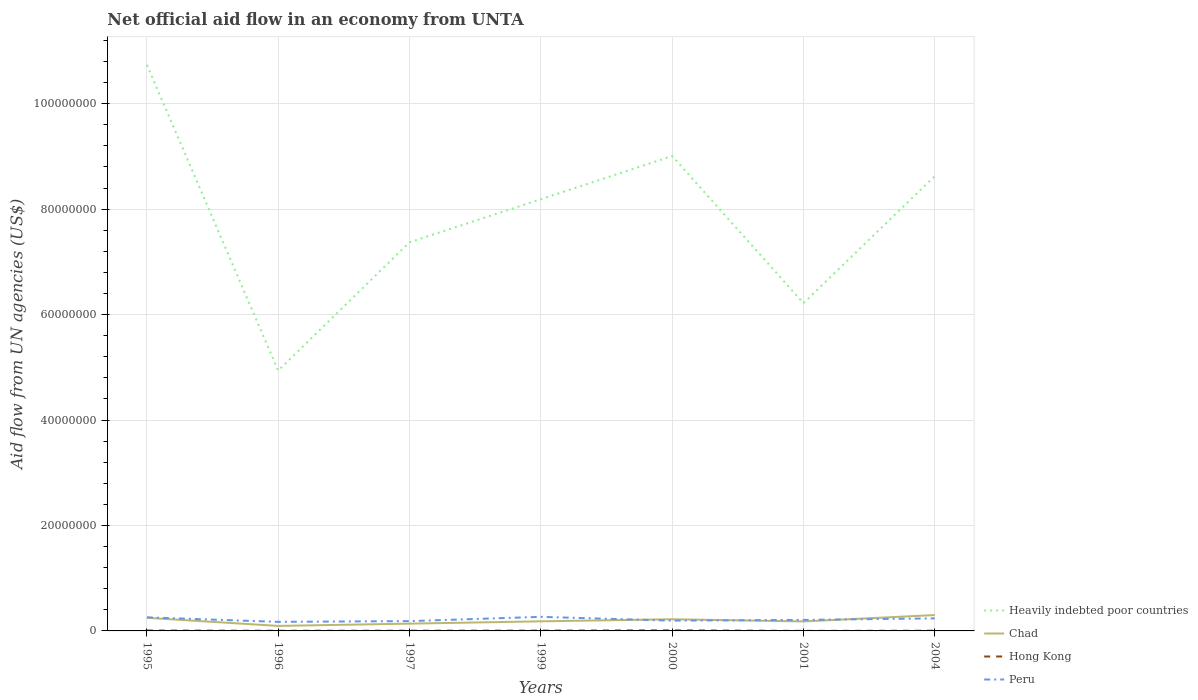Is the number of lines equal to the number of legend labels?
Your answer should be very brief. Yes. Across all years, what is the maximum net official aid flow in Hong Kong?
Offer a terse response. 10000. What is the total net official aid flow in Chad in the graph?
Your answer should be very brief. -8.50e+05. What is the difference between the highest and the second highest net official aid flow in Heavily indebted poor countries?
Ensure brevity in your answer.  5.80e+07. What is the difference between the highest and the lowest net official aid flow in Heavily indebted poor countries?
Your response must be concise. 4. Is the net official aid flow in Peru strictly greater than the net official aid flow in Hong Kong over the years?
Keep it short and to the point. No. How many years are there in the graph?
Give a very brief answer. 7. Does the graph contain any zero values?
Offer a very short reply. No. What is the title of the graph?
Ensure brevity in your answer.  Net official aid flow in an economy from UNTA. Does "Comoros" appear as one of the legend labels in the graph?
Ensure brevity in your answer.  No. What is the label or title of the X-axis?
Give a very brief answer. Years. What is the label or title of the Y-axis?
Your response must be concise. Aid flow from UN agencies (US$). What is the Aid flow from UN agencies (US$) in Heavily indebted poor countries in 1995?
Offer a very short reply. 1.07e+08. What is the Aid flow from UN agencies (US$) of Chad in 1995?
Provide a short and direct response. 2.49e+06. What is the Aid flow from UN agencies (US$) of Hong Kong in 1995?
Offer a very short reply. 8.00e+04. What is the Aid flow from UN agencies (US$) of Peru in 1995?
Provide a succinct answer. 2.58e+06. What is the Aid flow from UN agencies (US$) in Heavily indebted poor countries in 1996?
Ensure brevity in your answer.  4.94e+07. What is the Aid flow from UN agencies (US$) in Chad in 1996?
Make the answer very short. 9.50e+05. What is the Aid flow from UN agencies (US$) in Hong Kong in 1996?
Make the answer very short. 3.00e+04. What is the Aid flow from UN agencies (US$) of Peru in 1996?
Offer a terse response. 1.72e+06. What is the Aid flow from UN agencies (US$) in Heavily indebted poor countries in 1997?
Keep it short and to the point. 7.37e+07. What is the Aid flow from UN agencies (US$) in Chad in 1997?
Your response must be concise. 1.38e+06. What is the Aid flow from UN agencies (US$) in Peru in 1997?
Keep it short and to the point. 1.86e+06. What is the Aid flow from UN agencies (US$) in Heavily indebted poor countries in 1999?
Your response must be concise. 8.19e+07. What is the Aid flow from UN agencies (US$) in Chad in 1999?
Keep it short and to the point. 1.82e+06. What is the Aid flow from UN agencies (US$) in Peru in 1999?
Provide a succinct answer. 2.67e+06. What is the Aid flow from UN agencies (US$) in Heavily indebted poor countries in 2000?
Offer a very short reply. 9.01e+07. What is the Aid flow from UN agencies (US$) in Chad in 2000?
Offer a terse response. 2.21e+06. What is the Aid flow from UN agencies (US$) of Peru in 2000?
Your response must be concise. 1.95e+06. What is the Aid flow from UN agencies (US$) in Heavily indebted poor countries in 2001?
Your answer should be very brief. 6.22e+07. What is the Aid flow from UN agencies (US$) in Chad in 2001?
Offer a very short reply. 1.80e+06. What is the Aid flow from UN agencies (US$) of Peru in 2001?
Provide a short and direct response. 2.09e+06. What is the Aid flow from UN agencies (US$) in Heavily indebted poor countries in 2004?
Offer a terse response. 8.63e+07. What is the Aid flow from UN agencies (US$) in Chad in 2004?
Offer a terse response. 3.01e+06. What is the Aid flow from UN agencies (US$) in Hong Kong in 2004?
Your answer should be compact. 4.00e+04. What is the Aid flow from UN agencies (US$) of Peru in 2004?
Your answer should be very brief. 2.38e+06. Across all years, what is the maximum Aid flow from UN agencies (US$) of Heavily indebted poor countries?
Make the answer very short. 1.07e+08. Across all years, what is the maximum Aid flow from UN agencies (US$) in Chad?
Provide a short and direct response. 3.01e+06. Across all years, what is the maximum Aid flow from UN agencies (US$) of Hong Kong?
Offer a terse response. 1.10e+05. Across all years, what is the maximum Aid flow from UN agencies (US$) in Peru?
Make the answer very short. 2.67e+06. Across all years, what is the minimum Aid flow from UN agencies (US$) in Heavily indebted poor countries?
Offer a terse response. 4.94e+07. Across all years, what is the minimum Aid flow from UN agencies (US$) of Chad?
Give a very brief answer. 9.50e+05. Across all years, what is the minimum Aid flow from UN agencies (US$) of Peru?
Offer a very short reply. 1.72e+06. What is the total Aid flow from UN agencies (US$) of Heavily indebted poor countries in the graph?
Provide a short and direct response. 5.51e+08. What is the total Aid flow from UN agencies (US$) in Chad in the graph?
Give a very brief answer. 1.37e+07. What is the total Aid flow from UN agencies (US$) of Hong Kong in the graph?
Your response must be concise. 3.70e+05. What is the total Aid flow from UN agencies (US$) in Peru in the graph?
Offer a terse response. 1.52e+07. What is the difference between the Aid flow from UN agencies (US$) of Heavily indebted poor countries in 1995 and that in 1996?
Your response must be concise. 5.80e+07. What is the difference between the Aid flow from UN agencies (US$) of Chad in 1995 and that in 1996?
Offer a terse response. 1.54e+06. What is the difference between the Aid flow from UN agencies (US$) in Peru in 1995 and that in 1996?
Give a very brief answer. 8.60e+05. What is the difference between the Aid flow from UN agencies (US$) in Heavily indebted poor countries in 1995 and that in 1997?
Offer a very short reply. 3.36e+07. What is the difference between the Aid flow from UN agencies (US$) of Chad in 1995 and that in 1997?
Your response must be concise. 1.11e+06. What is the difference between the Aid flow from UN agencies (US$) in Peru in 1995 and that in 1997?
Provide a succinct answer. 7.20e+05. What is the difference between the Aid flow from UN agencies (US$) in Heavily indebted poor countries in 1995 and that in 1999?
Keep it short and to the point. 2.55e+07. What is the difference between the Aid flow from UN agencies (US$) of Chad in 1995 and that in 1999?
Your response must be concise. 6.70e+05. What is the difference between the Aid flow from UN agencies (US$) in Hong Kong in 1995 and that in 1999?
Your response must be concise. 2.00e+04. What is the difference between the Aid flow from UN agencies (US$) in Peru in 1995 and that in 1999?
Provide a short and direct response. -9.00e+04. What is the difference between the Aid flow from UN agencies (US$) in Heavily indebted poor countries in 1995 and that in 2000?
Offer a very short reply. 1.73e+07. What is the difference between the Aid flow from UN agencies (US$) of Chad in 1995 and that in 2000?
Your answer should be compact. 2.80e+05. What is the difference between the Aid flow from UN agencies (US$) in Hong Kong in 1995 and that in 2000?
Your answer should be very brief. -3.00e+04. What is the difference between the Aid flow from UN agencies (US$) of Peru in 1995 and that in 2000?
Give a very brief answer. 6.30e+05. What is the difference between the Aid flow from UN agencies (US$) of Heavily indebted poor countries in 1995 and that in 2001?
Offer a very short reply. 4.52e+07. What is the difference between the Aid flow from UN agencies (US$) in Chad in 1995 and that in 2001?
Ensure brevity in your answer.  6.90e+05. What is the difference between the Aid flow from UN agencies (US$) of Peru in 1995 and that in 2001?
Your answer should be very brief. 4.90e+05. What is the difference between the Aid flow from UN agencies (US$) in Heavily indebted poor countries in 1995 and that in 2004?
Give a very brief answer. 2.11e+07. What is the difference between the Aid flow from UN agencies (US$) of Chad in 1995 and that in 2004?
Offer a terse response. -5.20e+05. What is the difference between the Aid flow from UN agencies (US$) in Heavily indebted poor countries in 1996 and that in 1997?
Keep it short and to the point. -2.43e+07. What is the difference between the Aid flow from UN agencies (US$) in Chad in 1996 and that in 1997?
Give a very brief answer. -4.30e+05. What is the difference between the Aid flow from UN agencies (US$) in Hong Kong in 1996 and that in 1997?
Provide a short and direct response. -10000. What is the difference between the Aid flow from UN agencies (US$) in Heavily indebted poor countries in 1996 and that in 1999?
Offer a very short reply. -3.25e+07. What is the difference between the Aid flow from UN agencies (US$) in Chad in 1996 and that in 1999?
Offer a terse response. -8.70e+05. What is the difference between the Aid flow from UN agencies (US$) in Hong Kong in 1996 and that in 1999?
Your answer should be very brief. -3.00e+04. What is the difference between the Aid flow from UN agencies (US$) of Peru in 1996 and that in 1999?
Provide a succinct answer. -9.50e+05. What is the difference between the Aid flow from UN agencies (US$) of Heavily indebted poor countries in 1996 and that in 2000?
Make the answer very short. -4.07e+07. What is the difference between the Aid flow from UN agencies (US$) of Chad in 1996 and that in 2000?
Give a very brief answer. -1.26e+06. What is the difference between the Aid flow from UN agencies (US$) in Heavily indebted poor countries in 1996 and that in 2001?
Ensure brevity in your answer.  -1.28e+07. What is the difference between the Aid flow from UN agencies (US$) of Chad in 1996 and that in 2001?
Make the answer very short. -8.50e+05. What is the difference between the Aid flow from UN agencies (US$) of Hong Kong in 1996 and that in 2001?
Ensure brevity in your answer.  2.00e+04. What is the difference between the Aid flow from UN agencies (US$) in Peru in 1996 and that in 2001?
Ensure brevity in your answer.  -3.70e+05. What is the difference between the Aid flow from UN agencies (US$) in Heavily indebted poor countries in 1996 and that in 2004?
Your answer should be very brief. -3.69e+07. What is the difference between the Aid flow from UN agencies (US$) of Chad in 1996 and that in 2004?
Provide a short and direct response. -2.06e+06. What is the difference between the Aid flow from UN agencies (US$) in Peru in 1996 and that in 2004?
Your response must be concise. -6.60e+05. What is the difference between the Aid flow from UN agencies (US$) of Heavily indebted poor countries in 1997 and that in 1999?
Your answer should be compact. -8.16e+06. What is the difference between the Aid flow from UN agencies (US$) of Chad in 1997 and that in 1999?
Offer a very short reply. -4.40e+05. What is the difference between the Aid flow from UN agencies (US$) of Hong Kong in 1997 and that in 1999?
Provide a succinct answer. -2.00e+04. What is the difference between the Aid flow from UN agencies (US$) of Peru in 1997 and that in 1999?
Ensure brevity in your answer.  -8.10e+05. What is the difference between the Aid flow from UN agencies (US$) in Heavily indebted poor countries in 1997 and that in 2000?
Offer a very short reply. -1.64e+07. What is the difference between the Aid flow from UN agencies (US$) in Chad in 1997 and that in 2000?
Provide a succinct answer. -8.30e+05. What is the difference between the Aid flow from UN agencies (US$) in Heavily indebted poor countries in 1997 and that in 2001?
Your answer should be very brief. 1.16e+07. What is the difference between the Aid flow from UN agencies (US$) in Chad in 1997 and that in 2001?
Offer a very short reply. -4.20e+05. What is the difference between the Aid flow from UN agencies (US$) of Hong Kong in 1997 and that in 2001?
Provide a short and direct response. 3.00e+04. What is the difference between the Aid flow from UN agencies (US$) in Heavily indebted poor countries in 1997 and that in 2004?
Ensure brevity in your answer.  -1.25e+07. What is the difference between the Aid flow from UN agencies (US$) of Chad in 1997 and that in 2004?
Give a very brief answer. -1.63e+06. What is the difference between the Aid flow from UN agencies (US$) in Peru in 1997 and that in 2004?
Provide a short and direct response. -5.20e+05. What is the difference between the Aid flow from UN agencies (US$) of Heavily indebted poor countries in 1999 and that in 2000?
Provide a succinct answer. -8.20e+06. What is the difference between the Aid flow from UN agencies (US$) in Chad in 1999 and that in 2000?
Keep it short and to the point. -3.90e+05. What is the difference between the Aid flow from UN agencies (US$) of Peru in 1999 and that in 2000?
Give a very brief answer. 7.20e+05. What is the difference between the Aid flow from UN agencies (US$) of Heavily indebted poor countries in 1999 and that in 2001?
Offer a terse response. 1.97e+07. What is the difference between the Aid flow from UN agencies (US$) of Peru in 1999 and that in 2001?
Provide a succinct answer. 5.80e+05. What is the difference between the Aid flow from UN agencies (US$) of Heavily indebted poor countries in 1999 and that in 2004?
Ensure brevity in your answer.  -4.38e+06. What is the difference between the Aid flow from UN agencies (US$) in Chad in 1999 and that in 2004?
Give a very brief answer. -1.19e+06. What is the difference between the Aid flow from UN agencies (US$) in Hong Kong in 1999 and that in 2004?
Your answer should be compact. 2.00e+04. What is the difference between the Aid flow from UN agencies (US$) in Peru in 1999 and that in 2004?
Provide a short and direct response. 2.90e+05. What is the difference between the Aid flow from UN agencies (US$) of Heavily indebted poor countries in 2000 and that in 2001?
Your answer should be compact. 2.79e+07. What is the difference between the Aid flow from UN agencies (US$) in Chad in 2000 and that in 2001?
Your answer should be very brief. 4.10e+05. What is the difference between the Aid flow from UN agencies (US$) in Peru in 2000 and that in 2001?
Your answer should be compact. -1.40e+05. What is the difference between the Aid flow from UN agencies (US$) of Heavily indebted poor countries in 2000 and that in 2004?
Your response must be concise. 3.82e+06. What is the difference between the Aid flow from UN agencies (US$) in Chad in 2000 and that in 2004?
Your response must be concise. -8.00e+05. What is the difference between the Aid flow from UN agencies (US$) in Hong Kong in 2000 and that in 2004?
Your answer should be very brief. 7.00e+04. What is the difference between the Aid flow from UN agencies (US$) of Peru in 2000 and that in 2004?
Your answer should be compact. -4.30e+05. What is the difference between the Aid flow from UN agencies (US$) of Heavily indebted poor countries in 2001 and that in 2004?
Give a very brief answer. -2.41e+07. What is the difference between the Aid flow from UN agencies (US$) of Chad in 2001 and that in 2004?
Your answer should be compact. -1.21e+06. What is the difference between the Aid flow from UN agencies (US$) of Heavily indebted poor countries in 1995 and the Aid flow from UN agencies (US$) of Chad in 1996?
Provide a succinct answer. 1.06e+08. What is the difference between the Aid flow from UN agencies (US$) of Heavily indebted poor countries in 1995 and the Aid flow from UN agencies (US$) of Hong Kong in 1996?
Your response must be concise. 1.07e+08. What is the difference between the Aid flow from UN agencies (US$) in Heavily indebted poor countries in 1995 and the Aid flow from UN agencies (US$) in Peru in 1996?
Offer a terse response. 1.06e+08. What is the difference between the Aid flow from UN agencies (US$) in Chad in 1995 and the Aid flow from UN agencies (US$) in Hong Kong in 1996?
Your answer should be very brief. 2.46e+06. What is the difference between the Aid flow from UN agencies (US$) of Chad in 1995 and the Aid flow from UN agencies (US$) of Peru in 1996?
Provide a short and direct response. 7.70e+05. What is the difference between the Aid flow from UN agencies (US$) of Hong Kong in 1995 and the Aid flow from UN agencies (US$) of Peru in 1996?
Offer a terse response. -1.64e+06. What is the difference between the Aid flow from UN agencies (US$) in Heavily indebted poor countries in 1995 and the Aid flow from UN agencies (US$) in Chad in 1997?
Your response must be concise. 1.06e+08. What is the difference between the Aid flow from UN agencies (US$) in Heavily indebted poor countries in 1995 and the Aid flow from UN agencies (US$) in Hong Kong in 1997?
Keep it short and to the point. 1.07e+08. What is the difference between the Aid flow from UN agencies (US$) of Heavily indebted poor countries in 1995 and the Aid flow from UN agencies (US$) of Peru in 1997?
Make the answer very short. 1.06e+08. What is the difference between the Aid flow from UN agencies (US$) in Chad in 1995 and the Aid flow from UN agencies (US$) in Hong Kong in 1997?
Offer a terse response. 2.45e+06. What is the difference between the Aid flow from UN agencies (US$) in Chad in 1995 and the Aid flow from UN agencies (US$) in Peru in 1997?
Keep it short and to the point. 6.30e+05. What is the difference between the Aid flow from UN agencies (US$) in Hong Kong in 1995 and the Aid flow from UN agencies (US$) in Peru in 1997?
Offer a very short reply. -1.78e+06. What is the difference between the Aid flow from UN agencies (US$) of Heavily indebted poor countries in 1995 and the Aid flow from UN agencies (US$) of Chad in 1999?
Give a very brief answer. 1.06e+08. What is the difference between the Aid flow from UN agencies (US$) in Heavily indebted poor countries in 1995 and the Aid flow from UN agencies (US$) in Hong Kong in 1999?
Offer a terse response. 1.07e+08. What is the difference between the Aid flow from UN agencies (US$) of Heavily indebted poor countries in 1995 and the Aid flow from UN agencies (US$) of Peru in 1999?
Your response must be concise. 1.05e+08. What is the difference between the Aid flow from UN agencies (US$) of Chad in 1995 and the Aid flow from UN agencies (US$) of Hong Kong in 1999?
Keep it short and to the point. 2.43e+06. What is the difference between the Aid flow from UN agencies (US$) in Chad in 1995 and the Aid flow from UN agencies (US$) in Peru in 1999?
Ensure brevity in your answer.  -1.80e+05. What is the difference between the Aid flow from UN agencies (US$) in Hong Kong in 1995 and the Aid flow from UN agencies (US$) in Peru in 1999?
Make the answer very short. -2.59e+06. What is the difference between the Aid flow from UN agencies (US$) of Heavily indebted poor countries in 1995 and the Aid flow from UN agencies (US$) of Chad in 2000?
Offer a terse response. 1.05e+08. What is the difference between the Aid flow from UN agencies (US$) of Heavily indebted poor countries in 1995 and the Aid flow from UN agencies (US$) of Hong Kong in 2000?
Offer a very short reply. 1.07e+08. What is the difference between the Aid flow from UN agencies (US$) of Heavily indebted poor countries in 1995 and the Aid flow from UN agencies (US$) of Peru in 2000?
Keep it short and to the point. 1.05e+08. What is the difference between the Aid flow from UN agencies (US$) of Chad in 1995 and the Aid flow from UN agencies (US$) of Hong Kong in 2000?
Give a very brief answer. 2.38e+06. What is the difference between the Aid flow from UN agencies (US$) in Chad in 1995 and the Aid flow from UN agencies (US$) in Peru in 2000?
Ensure brevity in your answer.  5.40e+05. What is the difference between the Aid flow from UN agencies (US$) in Hong Kong in 1995 and the Aid flow from UN agencies (US$) in Peru in 2000?
Make the answer very short. -1.87e+06. What is the difference between the Aid flow from UN agencies (US$) of Heavily indebted poor countries in 1995 and the Aid flow from UN agencies (US$) of Chad in 2001?
Keep it short and to the point. 1.06e+08. What is the difference between the Aid flow from UN agencies (US$) in Heavily indebted poor countries in 1995 and the Aid flow from UN agencies (US$) in Hong Kong in 2001?
Your answer should be very brief. 1.07e+08. What is the difference between the Aid flow from UN agencies (US$) in Heavily indebted poor countries in 1995 and the Aid flow from UN agencies (US$) in Peru in 2001?
Your answer should be compact. 1.05e+08. What is the difference between the Aid flow from UN agencies (US$) in Chad in 1995 and the Aid flow from UN agencies (US$) in Hong Kong in 2001?
Ensure brevity in your answer.  2.48e+06. What is the difference between the Aid flow from UN agencies (US$) in Hong Kong in 1995 and the Aid flow from UN agencies (US$) in Peru in 2001?
Offer a terse response. -2.01e+06. What is the difference between the Aid flow from UN agencies (US$) in Heavily indebted poor countries in 1995 and the Aid flow from UN agencies (US$) in Chad in 2004?
Make the answer very short. 1.04e+08. What is the difference between the Aid flow from UN agencies (US$) of Heavily indebted poor countries in 1995 and the Aid flow from UN agencies (US$) of Hong Kong in 2004?
Ensure brevity in your answer.  1.07e+08. What is the difference between the Aid flow from UN agencies (US$) of Heavily indebted poor countries in 1995 and the Aid flow from UN agencies (US$) of Peru in 2004?
Make the answer very short. 1.05e+08. What is the difference between the Aid flow from UN agencies (US$) of Chad in 1995 and the Aid flow from UN agencies (US$) of Hong Kong in 2004?
Keep it short and to the point. 2.45e+06. What is the difference between the Aid flow from UN agencies (US$) in Chad in 1995 and the Aid flow from UN agencies (US$) in Peru in 2004?
Give a very brief answer. 1.10e+05. What is the difference between the Aid flow from UN agencies (US$) of Hong Kong in 1995 and the Aid flow from UN agencies (US$) of Peru in 2004?
Provide a succinct answer. -2.30e+06. What is the difference between the Aid flow from UN agencies (US$) in Heavily indebted poor countries in 1996 and the Aid flow from UN agencies (US$) in Chad in 1997?
Make the answer very short. 4.80e+07. What is the difference between the Aid flow from UN agencies (US$) of Heavily indebted poor countries in 1996 and the Aid flow from UN agencies (US$) of Hong Kong in 1997?
Make the answer very short. 4.93e+07. What is the difference between the Aid flow from UN agencies (US$) in Heavily indebted poor countries in 1996 and the Aid flow from UN agencies (US$) in Peru in 1997?
Make the answer very short. 4.75e+07. What is the difference between the Aid flow from UN agencies (US$) in Chad in 1996 and the Aid flow from UN agencies (US$) in Hong Kong in 1997?
Provide a short and direct response. 9.10e+05. What is the difference between the Aid flow from UN agencies (US$) in Chad in 1996 and the Aid flow from UN agencies (US$) in Peru in 1997?
Ensure brevity in your answer.  -9.10e+05. What is the difference between the Aid flow from UN agencies (US$) of Hong Kong in 1996 and the Aid flow from UN agencies (US$) of Peru in 1997?
Make the answer very short. -1.83e+06. What is the difference between the Aid flow from UN agencies (US$) of Heavily indebted poor countries in 1996 and the Aid flow from UN agencies (US$) of Chad in 1999?
Keep it short and to the point. 4.76e+07. What is the difference between the Aid flow from UN agencies (US$) of Heavily indebted poor countries in 1996 and the Aid flow from UN agencies (US$) of Hong Kong in 1999?
Provide a short and direct response. 4.93e+07. What is the difference between the Aid flow from UN agencies (US$) in Heavily indebted poor countries in 1996 and the Aid flow from UN agencies (US$) in Peru in 1999?
Provide a succinct answer. 4.67e+07. What is the difference between the Aid flow from UN agencies (US$) of Chad in 1996 and the Aid flow from UN agencies (US$) of Hong Kong in 1999?
Your answer should be compact. 8.90e+05. What is the difference between the Aid flow from UN agencies (US$) of Chad in 1996 and the Aid flow from UN agencies (US$) of Peru in 1999?
Make the answer very short. -1.72e+06. What is the difference between the Aid flow from UN agencies (US$) of Hong Kong in 1996 and the Aid flow from UN agencies (US$) of Peru in 1999?
Give a very brief answer. -2.64e+06. What is the difference between the Aid flow from UN agencies (US$) of Heavily indebted poor countries in 1996 and the Aid flow from UN agencies (US$) of Chad in 2000?
Keep it short and to the point. 4.72e+07. What is the difference between the Aid flow from UN agencies (US$) in Heavily indebted poor countries in 1996 and the Aid flow from UN agencies (US$) in Hong Kong in 2000?
Give a very brief answer. 4.93e+07. What is the difference between the Aid flow from UN agencies (US$) in Heavily indebted poor countries in 1996 and the Aid flow from UN agencies (US$) in Peru in 2000?
Offer a very short reply. 4.74e+07. What is the difference between the Aid flow from UN agencies (US$) of Chad in 1996 and the Aid flow from UN agencies (US$) of Hong Kong in 2000?
Your answer should be compact. 8.40e+05. What is the difference between the Aid flow from UN agencies (US$) in Chad in 1996 and the Aid flow from UN agencies (US$) in Peru in 2000?
Your answer should be compact. -1.00e+06. What is the difference between the Aid flow from UN agencies (US$) of Hong Kong in 1996 and the Aid flow from UN agencies (US$) of Peru in 2000?
Give a very brief answer. -1.92e+06. What is the difference between the Aid flow from UN agencies (US$) in Heavily indebted poor countries in 1996 and the Aid flow from UN agencies (US$) in Chad in 2001?
Your answer should be compact. 4.76e+07. What is the difference between the Aid flow from UN agencies (US$) in Heavily indebted poor countries in 1996 and the Aid flow from UN agencies (US$) in Hong Kong in 2001?
Keep it short and to the point. 4.94e+07. What is the difference between the Aid flow from UN agencies (US$) of Heavily indebted poor countries in 1996 and the Aid flow from UN agencies (US$) of Peru in 2001?
Offer a terse response. 4.73e+07. What is the difference between the Aid flow from UN agencies (US$) in Chad in 1996 and the Aid flow from UN agencies (US$) in Hong Kong in 2001?
Provide a short and direct response. 9.40e+05. What is the difference between the Aid flow from UN agencies (US$) of Chad in 1996 and the Aid flow from UN agencies (US$) of Peru in 2001?
Your answer should be very brief. -1.14e+06. What is the difference between the Aid flow from UN agencies (US$) of Hong Kong in 1996 and the Aid flow from UN agencies (US$) of Peru in 2001?
Keep it short and to the point. -2.06e+06. What is the difference between the Aid flow from UN agencies (US$) in Heavily indebted poor countries in 1996 and the Aid flow from UN agencies (US$) in Chad in 2004?
Offer a very short reply. 4.64e+07. What is the difference between the Aid flow from UN agencies (US$) in Heavily indebted poor countries in 1996 and the Aid flow from UN agencies (US$) in Hong Kong in 2004?
Make the answer very short. 4.93e+07. What is the difference between the Aid flow from UN agencies (US$) in Heavily indebted poor countries in 1996 and the Aid flow from UN agencies (US$) in Peru in 2004?
Give a very brief answer. 4.70e+07. What is the difference between the Aid flow from UN agencies (US$) of Chad in 1996 and the Aid flow from UN agencies (US$) of Hong Kong in 2004?
Ensure brevity in your answer.  9.10e+05. What is the difference between the Aid flow from UN agencies (US$) of Chad in 1996 and the Aid flow from UN agencies (US$) of Peru in 2004?
Offer a very short reply. -1.43e+06. What is the difference between the Aid flow from UN agencies (US$) in Hong Kong in 1996 and the Aid flow from UN agencies (US$) in Peru in 2004?
Keep it short and to the point. -2.35e+06. What is the difference between the Aid flow from UN agencies (US$) of Heavily indebted poor countries in 1997 and the Aid flow from UN agencies (US$) of Chad in 1999?
Provide a succinct answer. 7.19e+07. What is the difference between the Aid flow from UN agencies (US$) in Heavily indebted poor countries in 1997 and the Aid flow from UN agencies (US$) in Hong Kong in 1999?
Provide a short and direct response. 7.37e+07. What is the difference between the Aid flow from UN agencies (US$) in Heavily indebted poor countries in 1997 and the Aid flow from UN agencies (US$) in Peru in 1999?
Your answer should be very brief. 7.10e+07. What is the difference between the Aid flow from UN agencies (US$) in Chad in 1997 and the Aid flow from UN agencies (US$) in Hong Kong in 1999?
Offer a very short reply. 1.32e+06. What is the difference between the Aid flow from UN agencies (US$) of Chad in 1997 and the Aid flow from UN agencies (US$) of Peru in 1999?
Offer a very short reply. -1.29e+06. What is the difference between the Aid flow from UN agencies (US$) of Hong Kong in 1997 and the Aid flow from UN agencies (US$) of Peru in 1999?
Your response must be concise. -2.63e+06. What is the difference between the Aid flow from UN agencies (US$) of Heavily indebted poor countries in 1997 and the Aid flow from UN agencies (US$) of Chad in 2000?
Provide a short and direct response. 7.15e+07. What is the difference between the Aid flow from UN agencies (US$) in Heavily indebted poor countries in 1997 and the Aid flow from UN agencies (US$) in Hong Kong in 2000?
Ensure brevity in your answer.  7.36e+07. What is the difference between the Aid flow from UN agencies (US$) of Heavily indebted poor countries in 1997 and the Aid flow from UN agencies (US$) of Peru in 2000?
Provide a succinct answer. 7.18e+07. What is the difference between the Aid flow from UN agencies (US$) of Chad in 1997 and the Aid flow from UN agencies (US$) of Hong Kong in 2000?
Your answer should be very brief. 1.27e+06. What is the difference between the Aid flow from UN agencies (US$) in Chad in 1997 and the Aid flow from UN agencies (US$) in Peru in 2000?
Keep it short and to the point. -5.70e+05. What is the difference between the Aid flow from UN agencies (US$) of Hong Kong in 1997 and the Aid flow from UN agencies (US$) of Peru in 2000?
Provide a succinct answer. -1.91e+06. What is the difference between the Aid flow from UN agencies (US$) of Heavily indebted poor countries in 1997 and the Aid flow from UN agencies (US$) of Chad in 2001?
Your answer should be compact. 7.19e+07. What is the difference between the Aid flow from UN agencies (US$) of Heavily indebted poor countries in 1997 and the Aid flow from UN agencies (US$) of Hong Kong in 2001?
Your answer should be compact. 7.37e+07. What is the difference between the Aid flow from UN agencies (US$) in Heavily indebted poor countries in 1997 and the Aid flow from UN agencies (US$) in Peru in 2001?
Offer a terse response. 7.16e+07. What is the difference between the Aid flow from UN agencies (US$) of Chad in 1997 and the Aid flow from UN agencies (US$) of Hong Kong in 2001?
Offer a very short reply. 1.37e+06. What is the difference between the Aid flow from UN agencies (US$) of Chad in 1997 and the Aid flow from UN agencies (US$) of Peru in 2001?
Give a very brief answer. -7.10e+05. What is the difference between the Aid flow from UN agencies (US$) of Hong Kong in 1997 and the Aid flow from UN agencies (US$) of Peru in 2001?
Provide a short and direct response. -2.05e+06. What is the difference between the Aid flow from UN agencies (US$) in Heavily indebted poor countries in 1997 and the Aid flow from UN agencies (US$) in Chad in 2004?
Offer a terse response. 7.07e+07. What is the difference between the Aid flow from UN agencies (US$) of Heavily indebted poor countries in 1997 and the Aid flow from UN agencies (US$) of Hong Kong in 2004?
Your answer should be very brief. 7.37e+07. What is the difference between the Aid flow from UN agencies (US$) in Heavily indebted poor countries in 1997 and the Aid flow from UN agencies (US$) in Peru in 2004?
Provide a succinct answer. 7.13e+07. What is the difference between the Aid flow from UN agencies (US$) of Chad in 1997 and the Aid flow from UN agencies (US$) of Hong Kong in 2004?
Your answer should be very brief. 1.34e+06. What is the difference between the Aid flow from UN agencies (US$) in Chad in 1997 and the Aid flow from UN agencies (US$) in Peru in 2004?
Make the answer very short. -1.00e+06. What is the difference between the Aid flow from UN agencies (US$) in Hong Kong in 1997 and the Aid flow from UN agencies (US$) in Peru in 2004?
Give a very brief answer. -2.34e+06. What is the difference between the Aid flow from UN agencies (US$) in Heavily indebted poor countries in 1999 and the Aid flow from UN agencies (US$) in Chad in 2000?
Make the answer very short. 7.97e+07. What is the difference between the Aid flow from UN agencies (US$) of Heavily indebted poor countries in 1999 and the Aid flow from UN agencies (US$) of Hong Kong in 2000?
Offer a terse response. 8.18e+07. What is the difference between the Aid flow from UN agencies (US$) in Heavily indebted poor countries in 1999 and the Aid flow from UN agencies (US$) in Peru in 2000?
Your answer should be compact. 7.99e+07. What is the difference between the Aid flow from UN agencies (US$) of Chad in 1999 and the Aid flow from UN agencies (US$) of Hong Kong in 2000?
Keep it short and to the point. 1.71e+06. What is the difference between the Aid flow from UN agencies (US$) of Hong Kong in 1999 and the Aid flow from UN agencies (US$) of Peru in 2000?
Your answer should be compact. -1.89e+06. What is the difference between the Aid flow from UN agencies (US$) of Heavily indebted poor countries in 1999 and the Aid flow from UN agencies (US$) of Chad in 2001?
Keep it short and to the point. 8.01e+07. What is the difference between the Aid flow from UN agencies (US$) in Heavily indebted poor countries in 1999 and the Aid flow from UN agencies (US$) in Hong Kong in 2001?
Your answer should be compact. 8.19e+07. What is the difference between the Aid flow from UN agencies (US$) of Heavily indebted poor countries in 1999 and the Aid flow from UN agencies (US$) of Peru in 2001?
Your answer should be very brief. 7.98e+07. What is the difference between the Aid flow from UN agencies (US$) of Chad in 1999 and the Aid flow from UN agencies (US$) of Hong Kong in 2001?
Offer a very short reply. 1.81e+06. What is the difference between the Aid flow from UN agencies (US$) in Hong Kong in 1999 and the Aid flow from UN agencies (US$) in Peru in 2001?
Offer a very short reply. -2.03e+06. What is the difference between the Aid flow from UN agencies (US$) of Heavily indebted poor countries in 1999 and the Aid flow from UN agencies (US$) of Chad in 2004?
Your answer should be very brief. 7.89e+07. What is the difference between the Aid flow from UN agencies (US$) in Heavily indebted poor countries in 1999 and the Aid flow from UN agencies (US$) in Hong Kong in 2004?
Ensure brevity in your answer.  8.18e+07. What is the difference between the Aid flow from UN agencies (US$) in Heavily indebted poor countries in 1999 and the Aid flow from UN agencies (US$) in Peru in 2004?
Give a very brief answer. 7.95e+07. What is the difference between the Aid flow from UN agencies (US$) of Chad in 1999 and the Aid flow from UN agencies (US$) of Hong Kong in 2004?
Keep it short and to the point. 1.78e+06. What is the difference between the Aid flow from UN agencies (US$) of Chad in 1999 and the Aid flow from UN agencies (US$) of Peru in 2004?
Provide a succinct answer. -5.60e+05. What is the difference between the Aid flow from UN agencies (US$) in Hong Kong in 1999 and the Aid flow from UN agencies (US$) in Peru in 2004?
Offer a terse response. -2.32e+06. What is the difference between the Aid flow from UN agencies (US$) of Heavily indebted poor countries in 2000 and the Aid flow from UN agencies (US$) of Chad in 2001?
Your response must be concise. 8.83e+07. What is the difference between the Aid flow from UN agencies (US$) in Heavily indebted poor countries in 2000 and the Aid flow from UN agencies (US$) in Hong Kong in 2001?
Your answer should be compact. 9.01e+07. What is the difference between the Aid flow from UN agencies (US$) of Heavily indebted poor countries in 2000 and the Aid flow from UN agencies (US$) of Peru in 2001?
Ensure brevity in your answer.  8.80e+07. What is the difference between the Aid flow from UN agencies (US$) of Chad in 2000 and the Aid flow from UN agencies (US$) of Hong Kong in 2001?
Your answer should be very brief. 2.20e+06. What is the difference between the Aid flow from UN agencies (US$) in Chad in 2000 and the Aid flow from UN agencies (US$) in Peru in 2001?
Offer a terse response. 1.20e+05. What is the difference between the Aid flow from UN agencies (US$) in Hong Kong in 2000 and the Aid flow from UN agencies (US$) in Peru in 2001?
Make the answer very short. -1.98e+06. What is the difference between the Aid flow from UN agencies (US$) in Heavily indebted poor countries in 2000 and the Aid flow from UN agencies (US$) in Chad in 2004?
Make the answer very short. 8.71e+07. What is the difference between the Aid flow from UN agencies (US$) in Heavily indebted poor countries in 2000 and the Aid flow from UN agencies (US$) in Hong Kong in 2004?
Keep it short and to the point. 9.00e+07. What is the difference between the Aid flow from UN agencies (US$) of Heavily indebted poor countries in 2000 and the Aid flow from UN agencies (US$) of Peru in 2004?
Make the answer very short. 8.77e+07. What is the difference between the Aid flow from UN agencies (US$) in Chad in 2000 and the Aid flow from UN agencies (US$) in Hong Kong in 2004?
Offer a terse response. 2.17e+06. What is the difference between the Aid flow from UN agencies (US$) of Chad in 2000 and the Aid flow from UN agencies (US$) of Peru in 2004?
Your answer should be compact. -1.70e+05. What is the difference between the Aid flow from UN agencies (US$) of Hong Kong in 2000 and the Aid flow from UN agencies (US$) of Peru in 2004?
Keep it short and to the point. -2.27e+06. What is the difference between the Aid flow from UN agencies (US$) in Heavily indebted poor countries in 2001 and the Aid flow from UN agencies (US$) in Chad in 2004?
Your response must be concise. 5.92e+07. What is the difference between the Aid flow from UN agencies (US$) of Heavily indebted poor countries in 2001 and the Aid flow from UN agencies (US$) of Hong Kong in 2004?
Offer a very short reply. 6.21e+07. What is the difference between the Aid flow from UN agencies (US$) in Heavily indebted poor countries in 2001 and the Aid flow from UN agencies (US$) in Peru in 2004?
Provide a succinct answer. 5.98e+07. What is the difference between the Aid flow from UN agencies (US$) of Chad in 2001 and the Aid flow from UN agencies (US$) of Hong Kong in 2004?
Give a very brief answer. 1.76e+06. What is the difference between the Aid flow from UN agencies (US$) in Chad in 2001 and the Aid flow from UN agencies (US$) in Peru in 2004?
Make the answer very short. -5.80e+05. What is the difference between the Aid flow from UN agencies (US$) of Hong Kong in 2001 and the Aid flow from UN agencies (US$) of Peru in 2004?
Offer a terse response. -2.37e+06. What is the average Aid flow from UN agencies (US$) in Heavily indebted poor countries per year?
Your answer should be compact. 7.87e+07. What is the average Aid flow from UN agencies (US$) in Chad per year?
Offer a very short reply. 1.95e+06. What is the average Aid flow from UN agencies (US$) of Hong Kong per year?
Make the answer very short. 5.29e+04. What is the average Aid flow from UN agencies (US$) in Peru per year?
Your response must be concise. 2.18e+06. In the year 1995, what is the difference between the Aid flow from UN agencies (US$) in Heavily indebted poor countries and Aid flow from UN agencies (US$) in Chad?
Provide a succinct answer. 1.05e+08. In the year 1995, what is the difference between the Aid flow from UN agencies (US$) of Heavily indebted poor countries and Aid flow from UN agencies (US$) of Hong Kong?
Offer a very short reply. 1.07e+08. In the year 1995, what is the difference between the Aid flow from UN agencies (US$) of Heavily indebted poor countries and Aid flow from UN agencies (US$) of Peru?
Provide a short and direct response. 1.05e+08. In the year 1995, what is the difference between the Aid flow from UN agencies (US$) in Chad and Aid flow from UN agencies (US$) in Hong Kong?
Your answer should be very brief. 2.41e+06. In the year 1995, what is the difference between the Aid flow from UN agencies (US$) in Chad and Aid flow from UN agencies (US$) in Peru?
Your answer should be very brief. -9.00e+04. In the year 1995, what is the difference between the Aid flow from UN agencies (US$) of Hong Kong and Aid flow from UN agencies (US$) of Peru?
Give a very brief answer. -2.50e+06. In the year 1996, what is the difference between the Aid flow from UN agencies (US$) in Heavily indebted poor countries and Aid flow from UN agencies (US$) in Chad?
Ensure brevity in your answer.  4.84e+07. In the year 1996, what is the difference between the Aid flow from UN agencies (US$) in Heavily indebted poor countries and Aid flow from UN agencies (US$) in Hong Kong?
Provide a short and direct response. 4.94e+07. In the year 1996, what is the difference between the Aid flow from UN agencies (US$) of Heavily indebted poor countries and Aid flow from UN agencies (US$) of Peru?
Keep it short and to the point. 4.77e+07. In the year 1996, what is the difference between the Aid flow from UN agencies (US$) of Chad and Aid flow from UN agencies (US$) of Hong Kong?
Give a very brief answer. 9.20e+05. In the year 1996, what is the difference between the Aid flow from UN agencies (US$) in Chad and Aid flow from UN agencies (US$) in Peru?
Your answer should be very brief. -7.70e+05. In the year 1996, what is the difference between the Aid flow from UN agencies (US$) in Hong Kong and Aid flow from UN agencies (US$) in Peru?
Ensure brevity in your answer.  -1.69e+06. In the year 1997, what is the difference between the Aid flow from UN agencies (US$) of Heavily indebted poor countries and Aid flow from UN agencies (US$) of Chad?
Your response must be concise. 7.23e+07. In the year 1997, what is the difference between the Aid flow from UN agencies (US$) of Heavily indebted poor countries and Aid flow from UN agencies (US$) of Hong Kong?
Ensure brevity in your answer.  7.37e+07. In the year 1997, what is the difference between the Aid flow from UN agencies (US$) in Heavily indebted poor countries and Aid flow from UN agencies (US$) in Peru?
Offer a very short reply. 7.19e+07. In the year 1997, what is the difference between the Aid flow from UN agencies (US$) in Chad and Aid flow from UN agencies (US$) in Hong Kong?
Provide a succinct answer. 1.34e+06. In the year 1997, what is the difference between the Aid flow from UN agencies (US$) of Chad and Aid flow from UN agencies (US$) of Peru?
Offer a terse response. -4.80e+05. In the year 1997, what is the difference between the Aid flow from UN agencies (US$) of Hong Kong and Aid flow from UN agencies (US$) of Peru?
Make the answer very short. -1.82e+06. In the year 1999, what is the difference between the Aid flow from UN agencies (US$) of Heavily indebted poor countries and Aid flow from UN agencies (US$) of Chad?
Give a very brief answer. 8.01e+07. In the year 1999, what is the difference between the Aid flow from UN agencies (US$) in Heavily indebted poor countries and Aid flow from UN agencies (US$) in Hong Kong?
Your answer should be compact. 8.18e+07. In the year 1999, what is the difference between the Aid flow from UN agencies (US$) in Heavily indebted poor countries and Aid flow from UN agencies (US$) in Peru?
Your response must be concise. 7.92e+07. In the year 1999, what is the difference between the Aid flow from UN agencies (US$) of Chad and Aid flow from UN agencies (US$) of Hong Kong?
Offer a terse response. 1.76e+06. In the year 1999, what is the difference between the Aid flow from UN agencies (US$) of Chad and Aid flow from UN agencies (US$) of Peru?
Make the answer very short. -8.50e+05. In the year 1999, what is the difference between the Aid flow from UN agencies (US$) of Hong Kong and Aid flow from UN agencies (US$) of Peru?
Provide a short and direct response. -2.61e+06. In the year 2000, what is the difference between the Aid flow from UN agencies (US$) in Heavily indebted poor countries and Aid flow from UN agencies (US$) in Chad?
Your response must be concise. 8.79e+07. In the year 2000, what is the difference between the Aid flow from UN agencies (US$) of Heavily indebted poor countries and Aid flow from UN agencies (US$) of Hong Kong?
Give a very brief answer. 9.00e+07. In the year 2000, what is the difference between the Aid flow from UN agencies (US$) in Heavily indebted poor countries and Aid flow from UN agencies (US$) in Peru?
Your answer should be very brief. 8.81e+07. In the year 2000, what is the difference between the Aid flow from UN agencies (US$) in Chad and Aid flow from UN agencies (US$) in Hong Kong?
Provide a succinct answer. 2.10e+06. In the year 2000, what is the difference between the Aid flow from UN agencies (US$) of Hong Kong and Aid flow from UN agencies (US$) of Peru?
Your answer should be very brief. -1.84e+06. In the year 2001, what is the difference between the Aid flow from UN agencies (US$) in Heavily indebted poor countries and Aid flow from UN agencies (US$) in Chad?
Make the answer very short. 6.04e+07. In the year 2001, what is the difference between the Aid flow from UN agencies (US$) of Heavily indebted poor countries and Aid flow from UN agencies (US$) of Hong Kong?
Provide a short and direct response. 6.22e+07. In the year 2001, what is the difference between the Aid flow from UN agencies (US$) of Heavily indebted poor countries and Aid flow from UN agencies (US$) of Peru?
Your answer should be very brief. 6.01e+07. In the year 2001, what is the difference between the Aid flow from UN agencies (US$) of Chad and Aid flow from UN agencies (US$) of Hong Kong?
Provide a succinct answer. 1.79e+06. In the year 2001, what is the difference between the Aid flow from UN agencies (US$) of Chad and Aid flow from UN agencies (US$) of Peru?
Provide a succinct answer. -2.90e+05. In the year 2001, what is the difference between the Aid flow from UN agencies (US$) in Hong Kong and Aid flow from UN agencies (US$) in Peru?
Give a very brief answer. -2.08e+06. In the year 2004, what is the difference between the Aid flow from UN agencies (US$) in Heavily indebted poor countries and Aid flow from UN agencies (US$) in Chad?
Give a very brief answer. 8.32e+07. In the year 2004, what is the difference between the Aid flow from UN agencies (US$) of Heavily indebted poor countries and Aid flow from UN agencies (US$) of Hong Kong?
Your answer should be compact. 8.62e+07. In the year 2004, what is the difference between the Aid flow from UN agencies (US$) in Heavily indebted poor countries and Aid flow from UN agencies (US$) in Peru?
Provide a short and direct response. 8.39e+07. In the year 2004, what is the difference between the Aid flow from UN agencies (US$) in Chad and Aid flow from UN agencies (US$) in Hong Kong?
Ensure brevity in your answer.  2.97e+06. In the year 2004, what is the difference between the Aid flow from UN agencies (US$) of Chad and Aid flow from UN agencies (US$) of Peru?
Give a very brief answer. 6.30e+05. In the year 2004, what is the difference between the Aid flow from UN agencies (US$) in Hong Kong and Aid flow from UN agencies (US$) in Peru?
Keep it short and to the point. -2.34e+06. What is the ratio of the Aid flow from UN agencies (US$) in Heavily indebted poor countries in 1995 to that in 1996?
Your answer should be very brief. 2.17. What is the ratio of the Aid flow from UN agencies (US$) in Chad in 1995 to that in 1996?
Offer a terse response. 2.62. What is the ratio of the Aid flow from UN agencies (US$) of Hong Kong in 1995 to that in 1996?
Keep it short and to the point. 2.67. What is the ratio of the Aid flow from UN agencies (US$) of Peru in 1995 to that in 1996?
Provide a short and direct response. 1.5. What is the ratio of the Aid flow from UN agencies (US$) in Heavily indebted poor countries in 1995 to that in 1997?
Provide a succinct answer. 1.46. What is the ratio of the Aid flow from UN agencies (US$) of Chad in 1995 to that in 1997?
Give a very brief answer. 1.8. What is the ratio of the Aid flow from UN agencies (US$) of Peru in 1995 to that in 1997?
Keep it short and to the point. 1.39. What is the ratio of the Aid flow from UN agencies (US$) in Heavily indebted poor countries in 1995 to that in 1999?
Your answer should be compact. 1.31. What is the ratio of the Aid flow from UN agencies (US$) of Chad in 1995 to that in 1999?
Offer a terse response. 1.37. What is the ratio of the Aid flow from UN agencies (US$) of Hong Kong in 1995 to that in 1999?
Offer a terse response. 1.33. What is the ratio of the Aid flow from UN agencies (US$) of Peru in 1995 to that in 1999?
Your answer should be very brief. 0.97. What is the ratio of the Aid flow from UN agencies (US$) of Heavily indebted poor countries in 1995 to that in 2000?
Your answer should be very brief. 1.19. What is the ratio of the Aid flow from UN agencies (US$) in Chad in 1995 to that in 2000?
Make the answer very short. 1.13. What is the ratio of the Aid flow from UN agencies (US$) in Hong Kong in 1995 to that in 2000?
Provide a short and direct response. 0.73. What is the ratio of the Aid flow from UN agencies (US$) of Peru in 1995 to that in 2000?
Make the answer very short. 1.32. What is the ratio of the Aid flow from UN agencies (US$) of Heavily indebted poor countries in 1995 to that in 2001?
Your response must be concise. 1.73. What is the ratio of the Aid flow from UN agencies (US$) of Chad in 1995 to that in 2001?
Your answer should be compact. 1.38. What is the ratio of the Aid flow from UN agencies (US$) of Peru in 1995 to that in 2001?
Your answer should be very brief. 1.23. What is the ratio of the Aid flow from UN agencies (US$) in Heavily indebted poor countries in 1995 to that in 2004?
Keep it short and to the point. 1.24. What is the ratio of the Aid flow from UN agencies (US$) in Chad in 1995 to that in 2004?
Provide a short and direct response. 0.83. What is the ratio of the Aid flow from UN agencies (US$) in Peru in 1995 to that in 2004?
Keep it short and to the point. 1.08. What is the ratio of the Aid flow from UN agencies (US$) in Heavily indebted poor countries in 1996 to that in 1997?
Give a very brief answer. 0.67. What is the ratio of the Aid flow from UN agencies (US$) in Chad in 1996 to that in 1997?
Ensure brevity in your answer.  0.69. What is the ratio of the Aid flow from UN agencies (US$) in Hong Kong in 1996 to that in 1997?
Your response must be concise. 0.75. What is the ratio of the Aid flow from UN agencies (US$) of Peru in 1996 to that in 1997?
Provide a short and direct response. 0.92. What is the ratio of the Aid flow from UN agencies (US$) in Heavily indebted poor countries in 1996 to that in 1999?
Keep it short and to the point. 0.6. What is the ratio of the Aid flow from UN agencies (US$) in Chad in 1996 to that in 1999?
Give a very brief answer. 0.52. What is the ratio of the Aid flow from UN agencies (US$) in Peru in 1996 to that in 1999?
Provide a succinct answer. 0.64. What is the ratio of the Aid flow from UN agencies (US$) of Heavily indebted poor countries in 1996 to that in 2000?
Offer a very short reply. 0.55. What is the ratio of the Aid flow from UN agencies (US$) in Chad in 1996 to that in 2000?
Keep it short and to the point. 0.43. What is the ratio of the Aid flow from UN agencies (US$) in Hong Kong in 1996 to that in 2000?
Provide a short and direct response. 0.27. What is the ratio of the Aid flow from UN agencies (US$) of Peru in 1996 to that in 2000?
Provide a short and direct response. 0.88. What is the ratio of the Aid flow from UN agencies (US$) of Heavily indebted poor countries in 1996 to that in 2001?
Ensure brevity in your answer.  0.79. What is the ratio of the Aid flow from UN agencies (US$) in Chad in 1996 to that in 2001?
Provide a short and direct response. 0.53. What is the ratio of the Aid flow from UN agencies (US$) in Hong Kong in 1996 to that in 2001?
Your answer should be very brief. 3. What is the ratio of the Aid flow from UN agencies (US$) in Peru in 1996 to that in 2001?
Ensure brevity in your answer.  0.82. What is the ratio of the Aid flow from UN agencies (US$) in Heavily indebted poor countries in 1996 to that in 2004?
Provide a short and direct response. 0.57. What is the ratio of the Aid flow from UN agencies (US$) in Chad in 1996 to that in 2004?
Your response must be concise. 0.32. What is the ratio of the Aid flow from UN agencies (US$) in Peru in 1996 to that in 2004?
Make the answer very short. 0.72. What is the ratio of the Aid flow from UN agencies (US$) of Heavily indebted poor countries in 1997 to that in 1999?
Keep it short and to the point. 0.9. What is the ratio of the Aid flow from UN agencies (US$) in Chad in 1997 to that in 1999?
Provide a short and direct response. 0.76. What is the ratio of the Aid flow from UN agencies (US$) in Peru in 1997 to that in 1999?
Give a very brief answer. 0.7. What is the ratio of the Aid flow from UN agencies (US$) of Heavily indebted poor countries in 1997 to that in 2000?
Give a very brief answer. 0.82. What is the ratio of the Aid flow from UN agencies (US$) of Chad in 1997 to that in 2000?
Offer a terse response. 0.62. What is the ratio of the Aid flow from UN agencies (US$) in Hong Kong in 1997 to that in 2000?
Your answer should be very brief. 0.36. What is the ratio of the Aid flow from UN agencies (US$) in Peru in 1997 to that in 2000?
Your answer should be compact. 0.95. What is the ratio of the Aid flow from UN agencies (US$) of Heavily indebted poor countries in 1997 to that in 2001?
Provide a short and direct response. 1.19. What is the ratio of the Aid flow from UN agencies (US$) in Chad in 1997 to that in 2001?
Your answer should be very brief. 0.77. What is the ratio of the Aid flow from UN agencies (US$) in Hong Kong in 1997 to that in 2001?
Offer a very short reply. 4. What is the ratio of the Aid flow from UN agencies (US$) in Peru in 1997 to that in 2001?
Ensure brevity in your answer.  0.89. What is the ratio of the Aid flow from UN agencies (US$) of Heavily indebted poor countries in 1997 to that in 2004?
Offer a very short reply. 0.85. What is the ratio of the Aid flow from UN agencies (US$) of Chad in 1997 to that in 2004?
Your response must be concise. 0.46. What is the ratio of the Aid flow from UN agencies (US$) in Hong Kong in 1997 to that in 2004?
Offer a very short reply. 1. What is the ratio of the Aid flow from UN agencies (US$) of Peru in 1997 to that in 2004?
Offer a very short reply. 0.78. What is the ratio of the Aid flow from UN agencies (US$) in Heavily indebted poor countries in 1999 to that in 2000?
Offer a very short reply. 0.91. What is the ratio of the Aid flow from UN agencies (US$) in Chad in 1999 to that in 2000?
Ensure brevity in your answer.  0.82. What is the ratio of the Aid flow from UN agencies (US$) in Hong Kong in 1999 to that in 2000?
Give a very brief answer. 0.55. What is the ratio of the Aid flow from UN agencies (US$) in Peru in 1999 to that in 2000?
Your answer should be very brief. 1.37. What is the ratio of the Aid flow from UN agencies (US$) of Heavily indebted poor countries in 1999 to that in 2001?
Keep it short and to the point. 1.32. What is the ratio of the Aid flow from UN agencies (US$) of Chad in 1999 to that in 2001?
Offer a terse response. 1.01. What is the ratio of the Aid flow from UN agencies (US$) in Peru in 1999 to that in 2001?
Offer a terse response. 1.28. What is the ratio of the Aid flow from UN agencies (US$) of Heavily indebted poor countries in 1999 to that in 2004?
Make the answer very short. 0.95. What is the ratio of the Aid flow from UN agencies (US$) in Chad in 1999 to that in 2004?
Keep it short and to the point. 0.6. What is the ratio of the Aid flow from UN agencies (US$) in Hong Kong in 1999 to that in 2004?
Your response must be concise. 1.5. What is the ratio of the Aid flow from UN agencies (US$) in Peru in 1999 to that in 2004?
Offer a terse response. 1.12. What is the ratio of the Aid flow from UN agencies (US$) in Heavily indebted poor countries in 2000 to that in 2001?
Offer a very short reply. 1.45. What is the ratio of the Aid flow from UN agencies (US$) of Chad in 2000 to that in 2001?
Provide a short and direct response. 1.23. What is the ratio of the Aid flow from UN agencies (US$) of Hong Kong in 2000 to that in 2001?
Your answer should be very brief. 11. What is the ratio of the Aid flow from UN agencies (US$) in Peru in 2000 to that in 2001?
Offer a very short reply. 0.93. What is the ratio of the Aid flow from UN agencies (US$) in Heavily indebted poor countries in 2000 to that in 2004?
Give a very brief answer. 1.04. What is the ratio of the Aid flow from UN agencies (US$) of Chad in 2000 to that in 2004?
Provide a succinct answer. 0.73. What is the ratio of the Aid flow from UN agencies (US$) of Hong Kong in 2000 to that in 2004?
Provide a succinct answer. 2.75. What is the ratio of the Aid flow from UN agencies (US$) of Peru in 2000 to that in 2004?
Your answer should be compact. 0.82. What is the ratio of the Aid flow from UN agencies (US$) in Heavily indebted poor countries in 2001 to that in 2004?
Your response must be concise. 0.72. What is the ratio of the Aid flow from UN agencies (US$) in Chad in 2001 to that in 2004?
Your answer should be very brief. 0.6. What is the ratio of the Aid flow from UN agencies (US$) of Hong Kong in 2001 to that in 2004?
Offer a terse response. 0.25. What is the ratio of the Aid flow from UN agencies (US$) in Peru in 2001 to that in 2004?
Your response must be concise. 0.88. What is the difference between the highest and the second highest Aid flow from UN agencies (US$) of Heavily indebted poor countries?
Ensure brevity in your answer.  1.73e+07. What is the difference between the highest and the second highest Aid flow from UN agencies (US$) in Chad?
Provide a succinct answer. 5.20e+05. What is the difference between the highest and the second highest Aid flow from UN agencies (US$) in Peru?
Provide a succinct answer. 9.00e+04. What is the difference between the highest and the lowest Aid flow from UN agencies (US$) of Heavily indebted poor countries?
Ensure brevity in your answer.  5.80e+07. What is the difference between the highest and the lowest Aid flow from UN agencies (US$) of Chad?
Provide a short and direct response. 2.06e+06. What is the difference between the highest and the lowest Aid flow from UN agencies (US$) in Hong Kong?
Give a very brief answer. 1.00e+05. What is the difference between the highest and the lowest Aid flow from UN agencies (US$) in Peru?
Your answer should be very brief. 9.50e+05. 